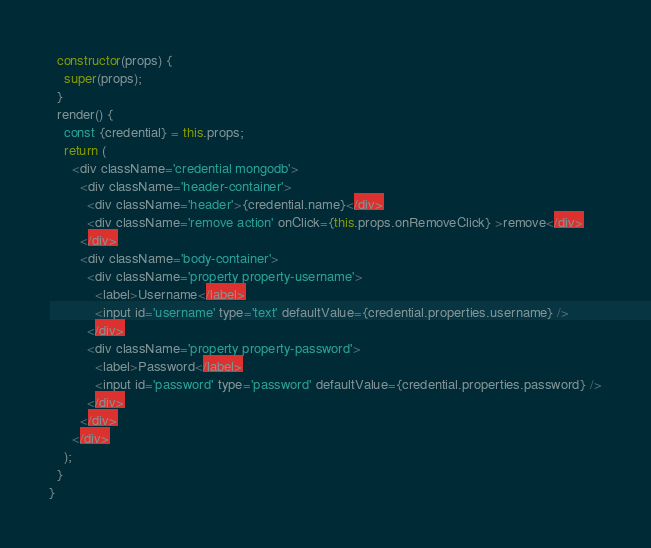<code> <loc_0><loc_0><loc_500><loc_500><_JavaScript_>
  constructor(props) {
    super(props);
  }
  render() {
    const {credential} = this.props;
    return (
      <div className='credential mongodb'>
        <div className='header-container'>
          <div className='header'>{credential.name}</div>
          <div className='remove action' onClick={this.props.onRemoveClick} >remove</div>
        </div>
        <div className='body-container'>
          <div className='property property-username'>
            <label>Username</label>
            <input id='username' type='text' defaultValue={credential.properties.username} />
          </div>
          <div className='property property-password'>
            <label>Password</label>
            <input id='password' type='password' defaultValue={credential.properties.password} />
          </div>
        </div>
      </div>
    );
  }
}
</code> 